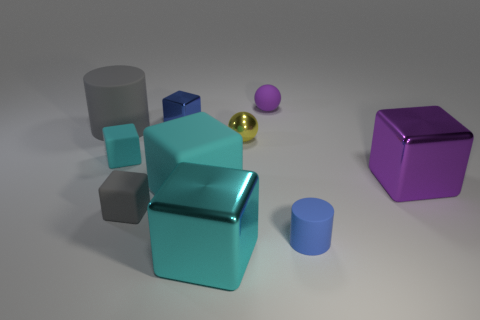Are there any tiny blue things that are behind the blue thing behind the large object that is to the left of the tiny gray matte thing?
Provide a succinct answer. No. There is a tiny cyan thing; are there any gray objects to the left of it?
Make the answer very short. Yes. Are there any small matte things that have the same color as the small cylinder?
Keep it short and to the point. No. What number of big things are either metallic balls or cyan rubber blocks?
Make the answer very short. 1. Do the large thing that is to the right of the large cyan metallic block and the gray block have the same material?
Give a very brief answer. No. There is a metal object that is right of the tiny blue object in front of the big metal cube that is right of the small blue matte cylinder; what is its shape?
Offer a terse response. Cube. What number of cyan objects are large metal objects or cubes?
Give a very brief answer. 3. Are there the same number of purple shiny blocks that are in front of the purple metallic thing and cyan things on the right side of the purple rubber object?
Ensure brevity in your answer.  Yes. There is a big object that is behind the tiny yellow metal object; is it the same shape as the tiny blue thing in front of the big purple block?
Your response must be concise. Yes. Is there any other thing that is the same shape as the yellow shiny object?
Offer a very short reply. Yes. 